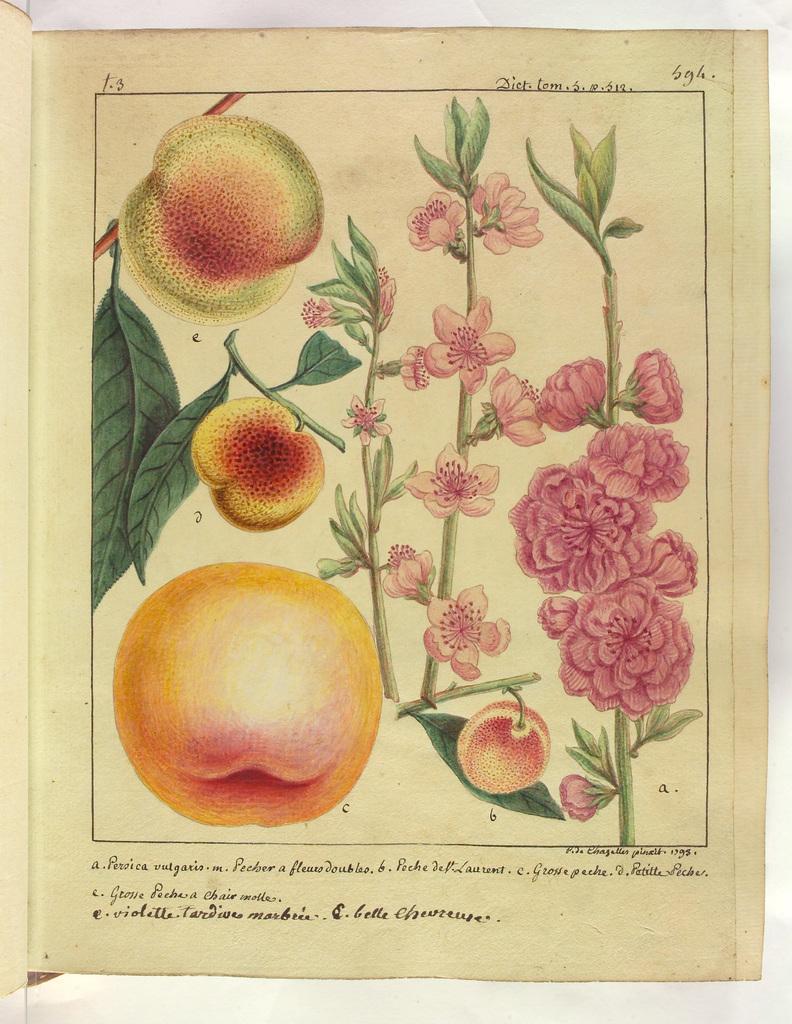How would you summarize this image in a sentence or two? in the given picture i can see apple which is drawn and leaves , a stem , flowers and also there is something content written. 